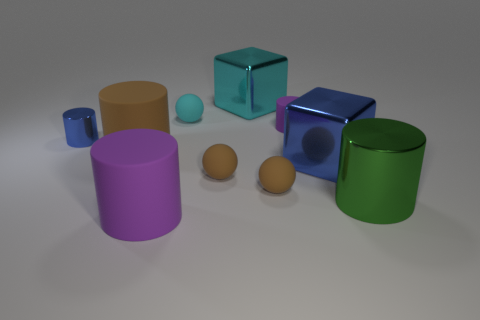Subtract all small cyan spheres. How many spheres are left? 2 Subtract all purple cylinders. How many cylinders are left? 3 Subtract all red blocks. How many brown spheres are left? 2 Subtract all cubes. How many objects are left? 8 Subtract all yellow cylinders. Subtract all cyan blocks. How many cylinders are left? 5 Subtract all tiny objects. Subtract all matte cylinders. How many objects are left? 2 Add 1 big cylinders. How many big cylinders are left? 4 Add 6 small yellow rubber objects. How many small yellow rubber objects exist? 6 Subtract 0 green blocks. How many objects are left? 10 